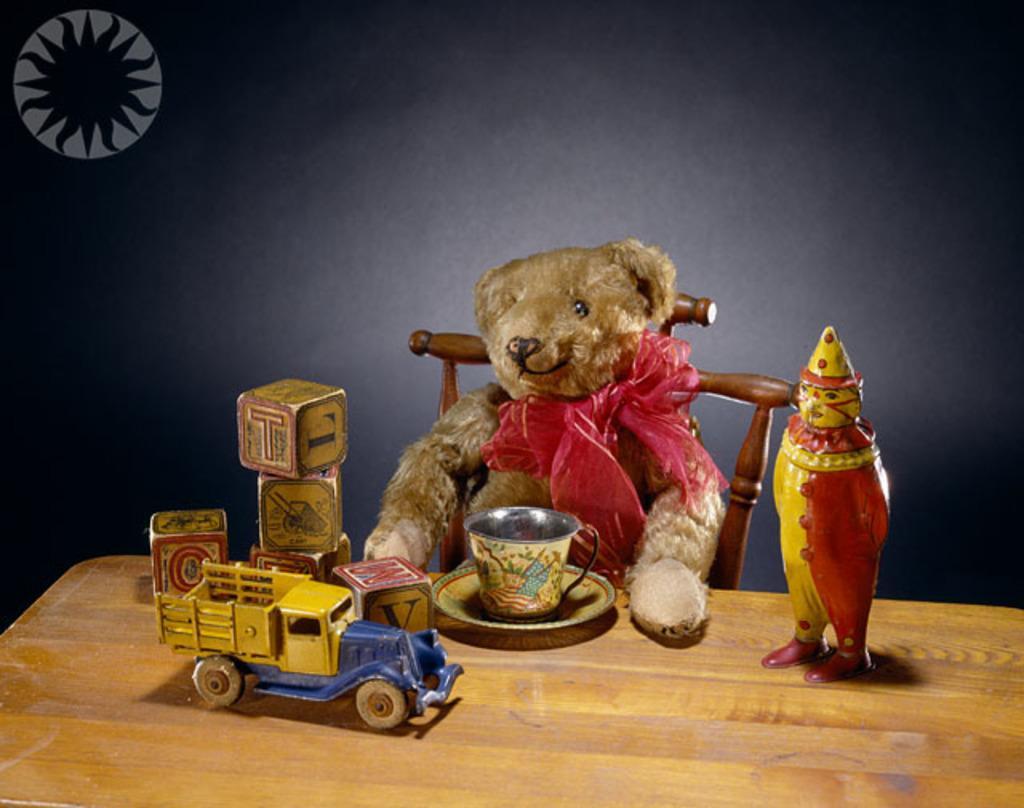Can you describe this image briefly? In this picture I can see there is a teddy bear on the chair and there is a table here and there are some dolls, there is a cup and a saucer and there is a black wall in the floor. 